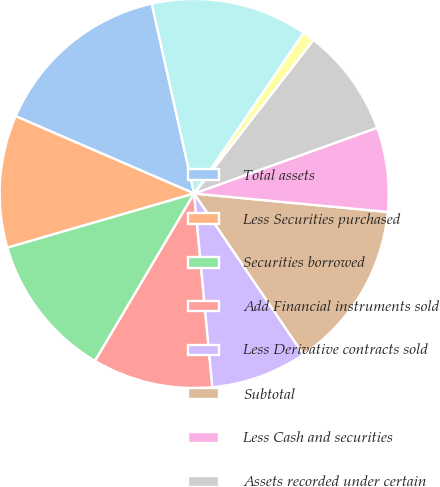<chart> <loc_0><loc_0><loc_500><loc_500><pie_chart><fcel>Total assets<fcel>Less Securities purchased<fcel>Securities borrowed<fcel>Add Financial instruments sold<fcel>Less Derivative contracts sold<fcel>Subtotal<fcel>Less Cash and securities<fcel>Assets recorded under certain<fcel>Goodwill and net intangible<fcel>Adjusted assets<nl><fcel>15.0%<fcel>11.0%<fcel>12.0%<fcel>10.0%<fcel>8.0%<fcel>14.0%<fcel>7.0%<fcel>9.0%<fcel>1.0%<fcel>13.0%<nl></chart> 